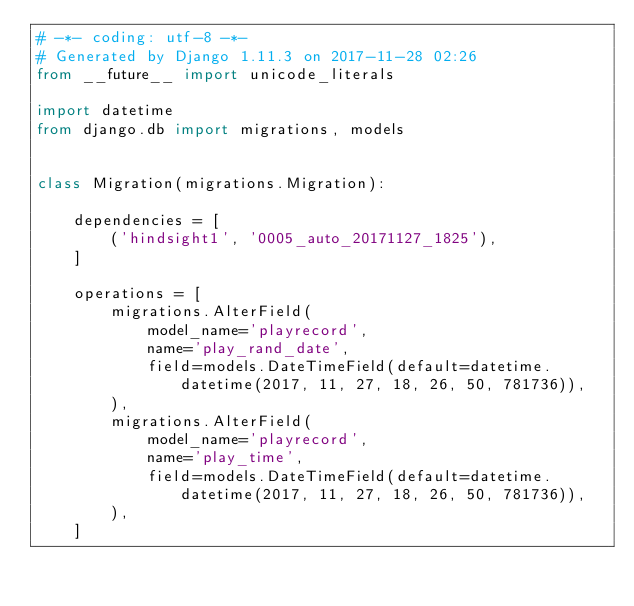<code> <loc_0><loc_0><loc_500><loc_500><_Python_># -*- coding: utf-8 -*-
# Generated by Django 1.11.3 on 2017-11-28 02:26
from __future__ import unicode_literals

import datetime
from django.db import migrations, models


class Migration(migrations.Migration):

    dependencies = [
        ('hindsight1', '0005_auto_20171127_1825'),
    ]

    operations = [
        migrations.AlterField(
            model_name='playrecord',
            name='play_rand_date',
            field=models.DateTimeField(default=datetime.datetime(2017, 11, 27, 18, 26, 50, 781736)),
        ),
        migrations.AlterField(
            model_name='playrecord',
            name='play_time',
            field=models.DateTimeField(default=datetime.datetime(2017, 11, 27, 18, 26, 50, 781736)),
        ),
    ]
</code> 